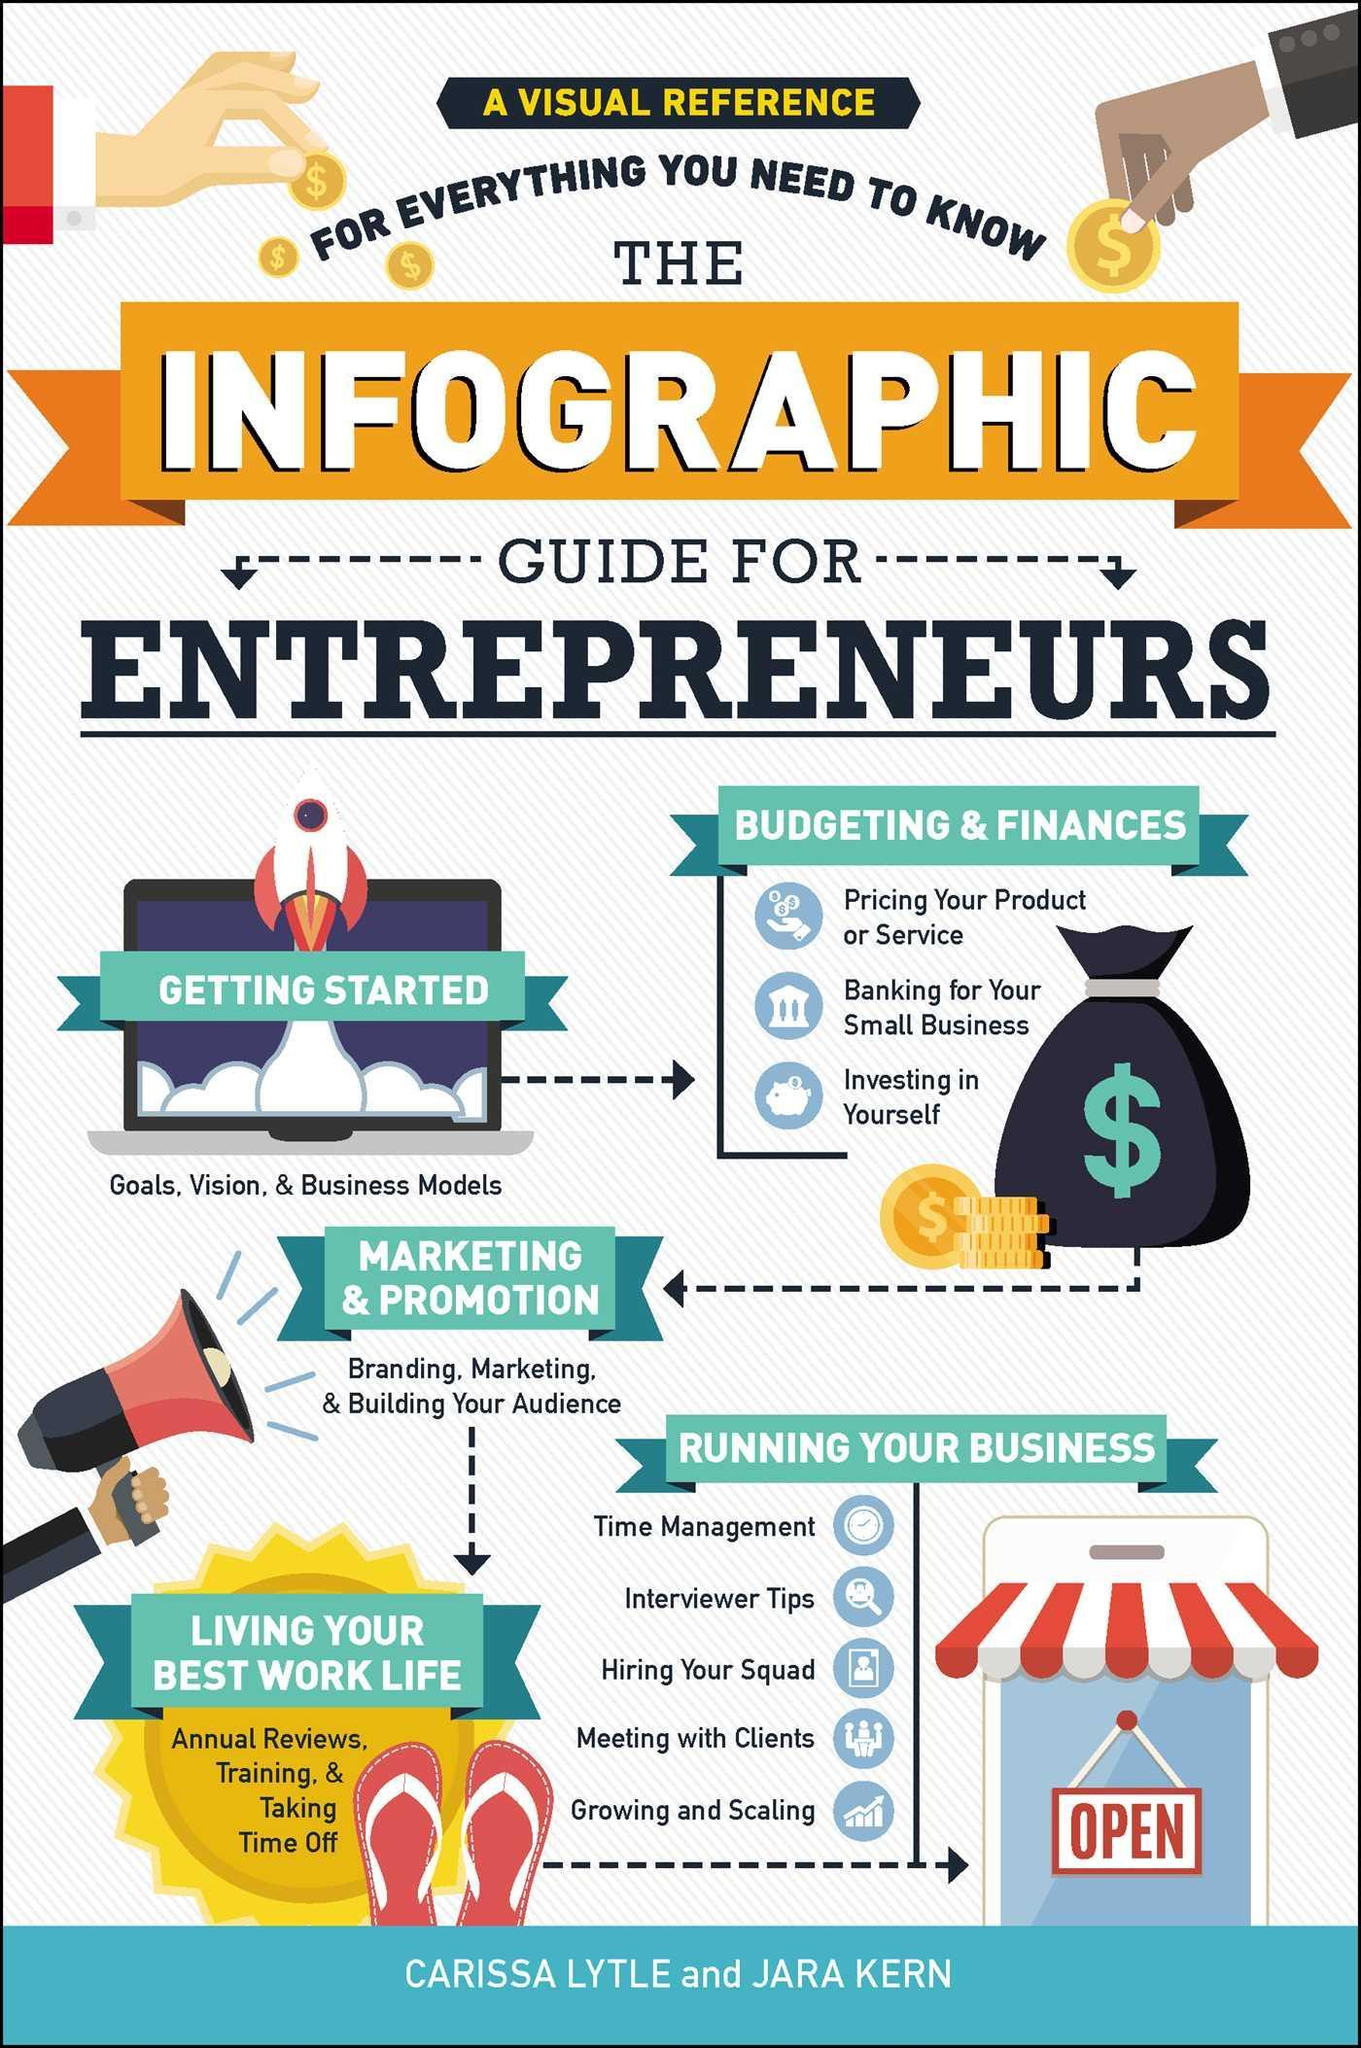How many steps are to be followed as a guide for entrepreneurs?
Answer the question with a short phrase. 5 